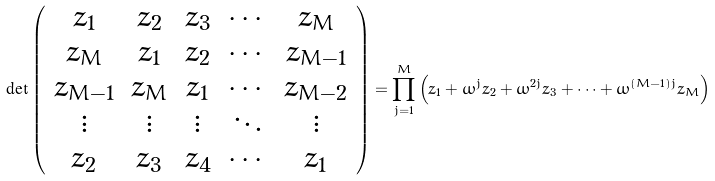<formula> <loc_0><loc_0><loc_500><loc_500>\det \left ( \begin{array} { c c c c c } z _ { 1 } & z _ { 2 } & z _ { 3 } & \cdots & z _ { M } \\ z _ { M } & z _ { 1 } & z _ { 2 } & \cdots & z _ { M - 1 } \\ z _ { M - 1 } & z _ { M } & z _ { 1 } & \cdots & z _ { M - 2 } \\ \vdots & \vdots & \vdots & \ddots & \vdots \\ z _ { 2 } & z _ { 3 } & z _ { 4 } & \cdots & z _ { 1 } \end{array} \right ) = \prod _ { j = 1 } ^ { M } \left ( z _ { 1 } + \omega ^ { j } z _ { 2 } + \omega ^ { 2 j } z _ { 3 } + \cdots + \omega ^ { ( M - 1 ) j } z _ { M } \right )</formula> 